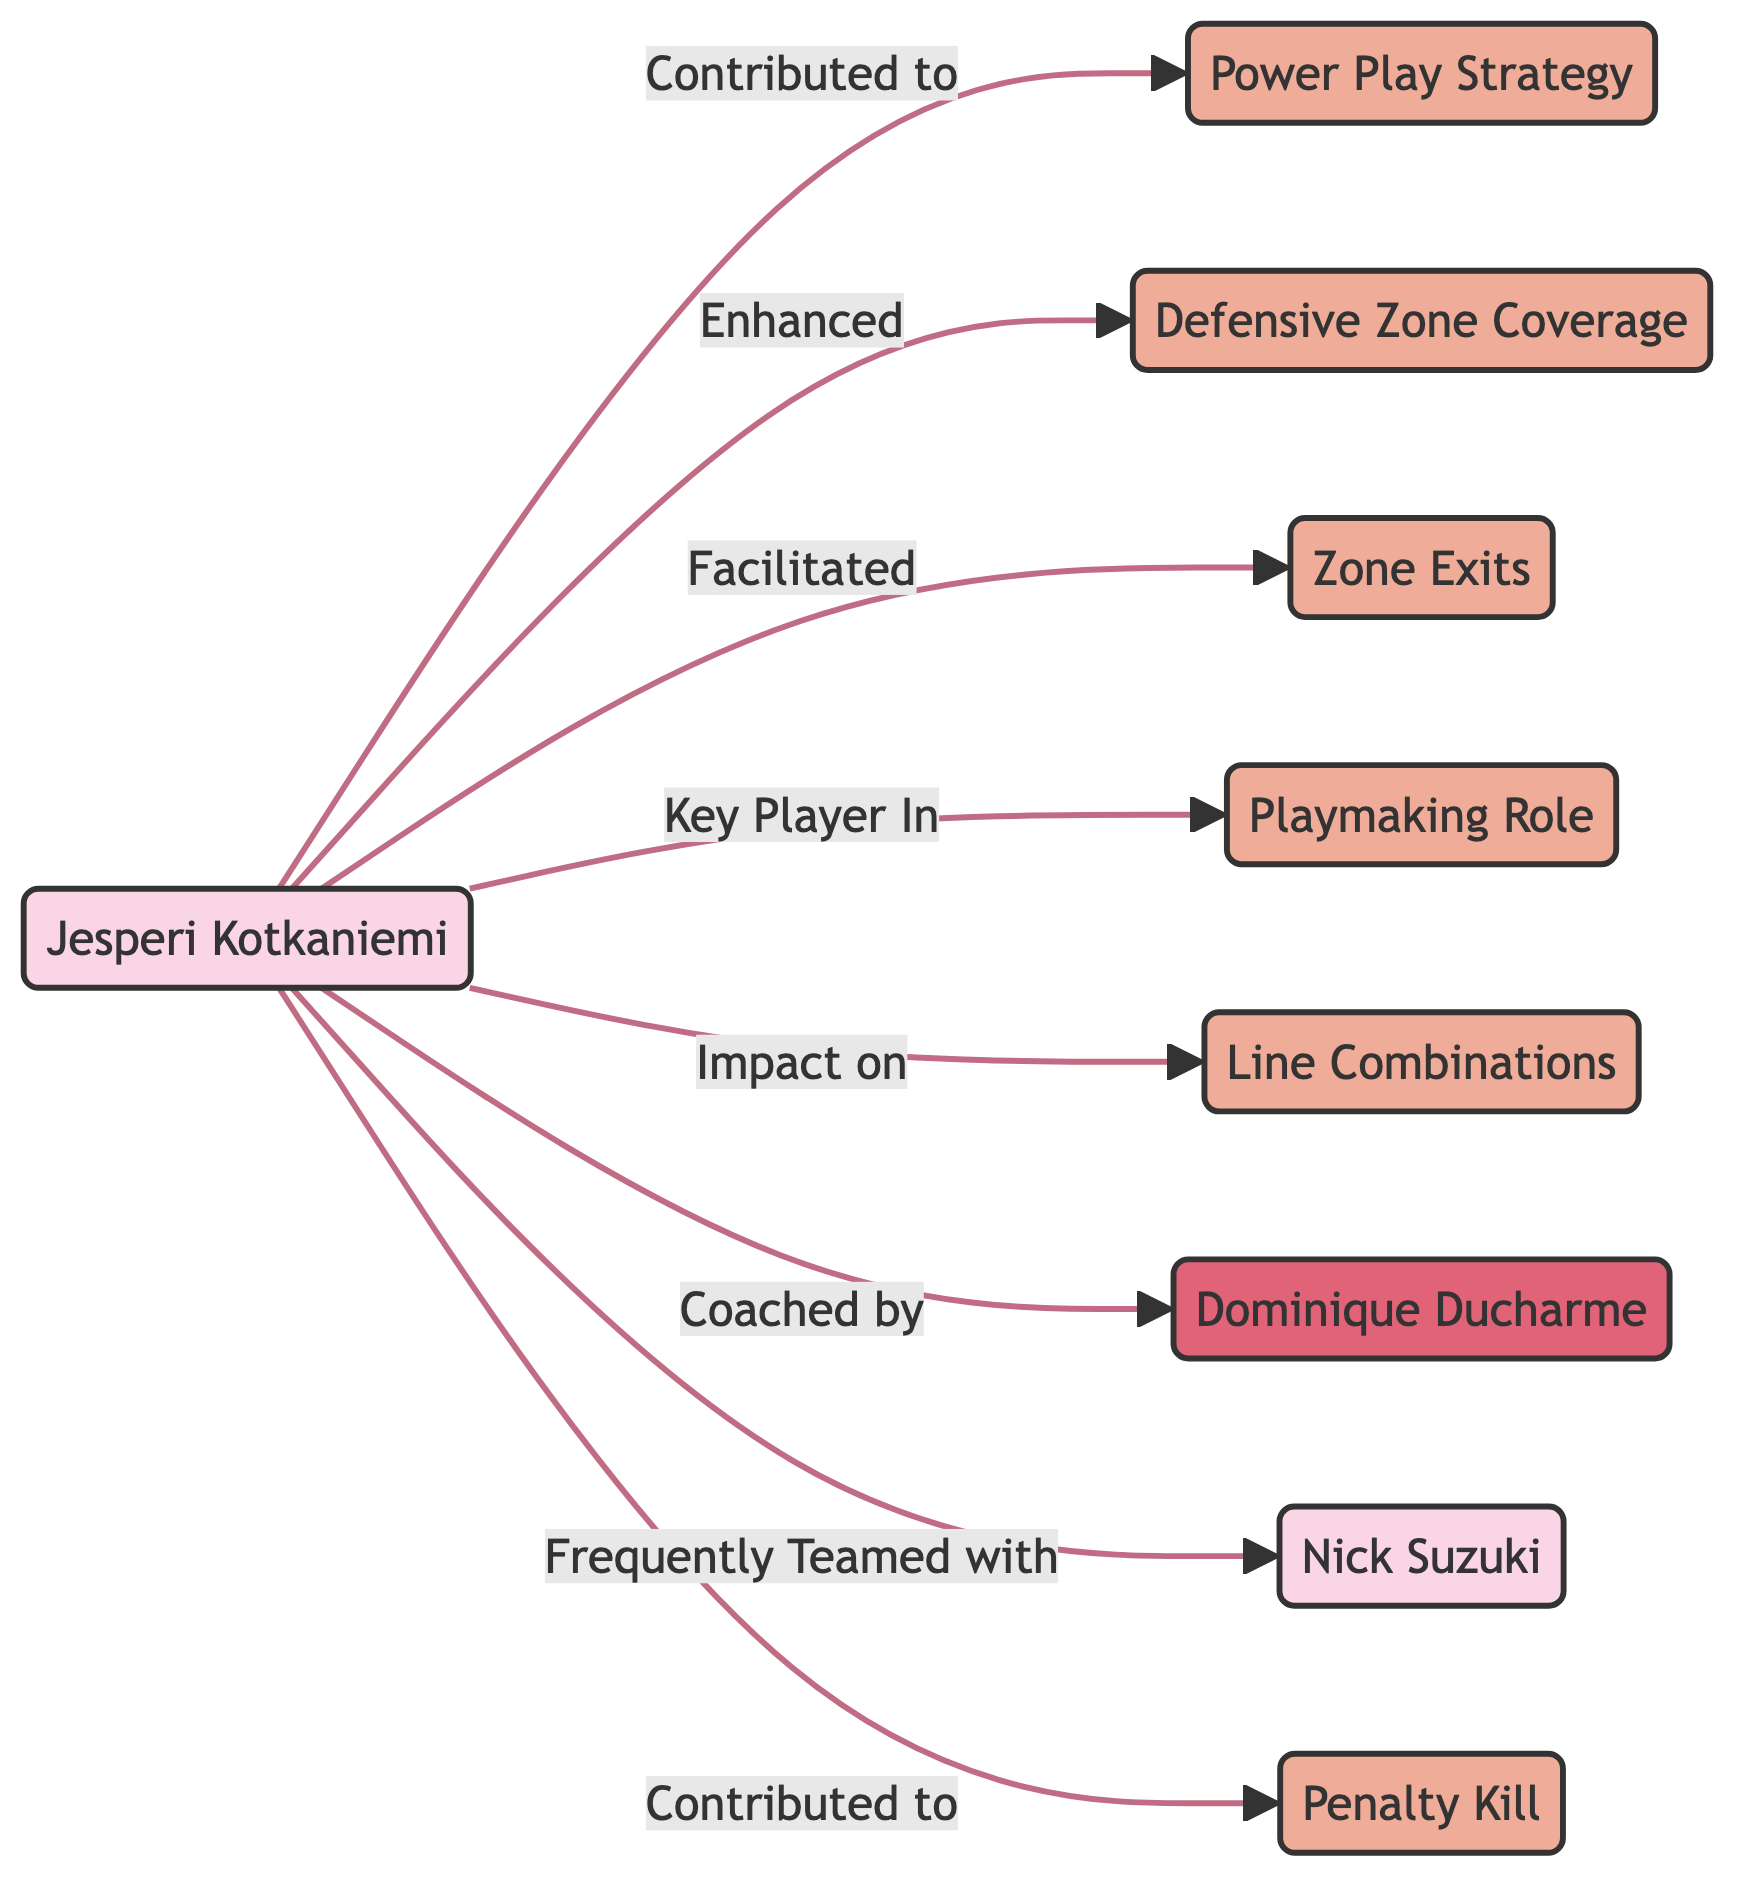What player is connected to the Power Play Strategy? The diagram shows a direct connection from Jesperi Kotkaniemi to the Power Play Strategy, indicating his contribution to this area.
Answer: Jesperi Kotkaniemi How many nodes are in the diagram? Counting each distinct element represented in the diagram, there are a total of 9 nodes including players, strategies, and the coach.
Answer: 9 What role did Kotkaniemi play in the Zone Exits? The directed edge from Kotkaniemi to Zone Exits indicates he facilitated this aspect of the game, suggesting his involvement in helping the team move out of their defensive zone effectively.
Answer: Facilitated Which player was frequently teamed with Kotkaniemi? The connection labeled "Frequently Teamed with" indicates a direct relationship, which identifies Nick Suzuki as the player who regularly played alongside him during his tenure.
Answer: Nick Suzuki What connection involves the coach Dominique Ducharme? The diagram shows a direct edge from Kotkaniemi to Dominique Ducharme labeled "Coached by," establishing the relationship between them under the coaching paradigm.
Answer: Coached by What aspect of the game was enhanced by Kotkaniemi? The edge labeled "Enhanced" from Kotkaniemi to Defensive Zone Coverage signifies his contribution to improving the team's strategies in defending against opponent's advances.
Answer: Defensive Zone Coverage How many strategies are mentioned in the diagram? The diagram features a total of 6 strategy nodes, each representing different aspects of gameplay that Kotkaniemi was involved in during his time with the team.
Answer: 6 What impact did Kotkaniemi have on Line Combinations? The link labeled "Impact on" illustrates his significant influence on the team's line configurations, suggesting he was a key player in shaping how the team arranged its forwards during games.
Answer: Impact on What defensive strategy did Kotkaniemi contribute to? The edge indicating a contribution shows a direct connection between Kotkaniemi and Penalty Kill, revealing his role in the team's efforts to thwart opponent scoring during penalties.
Answer: Penalty Kill 